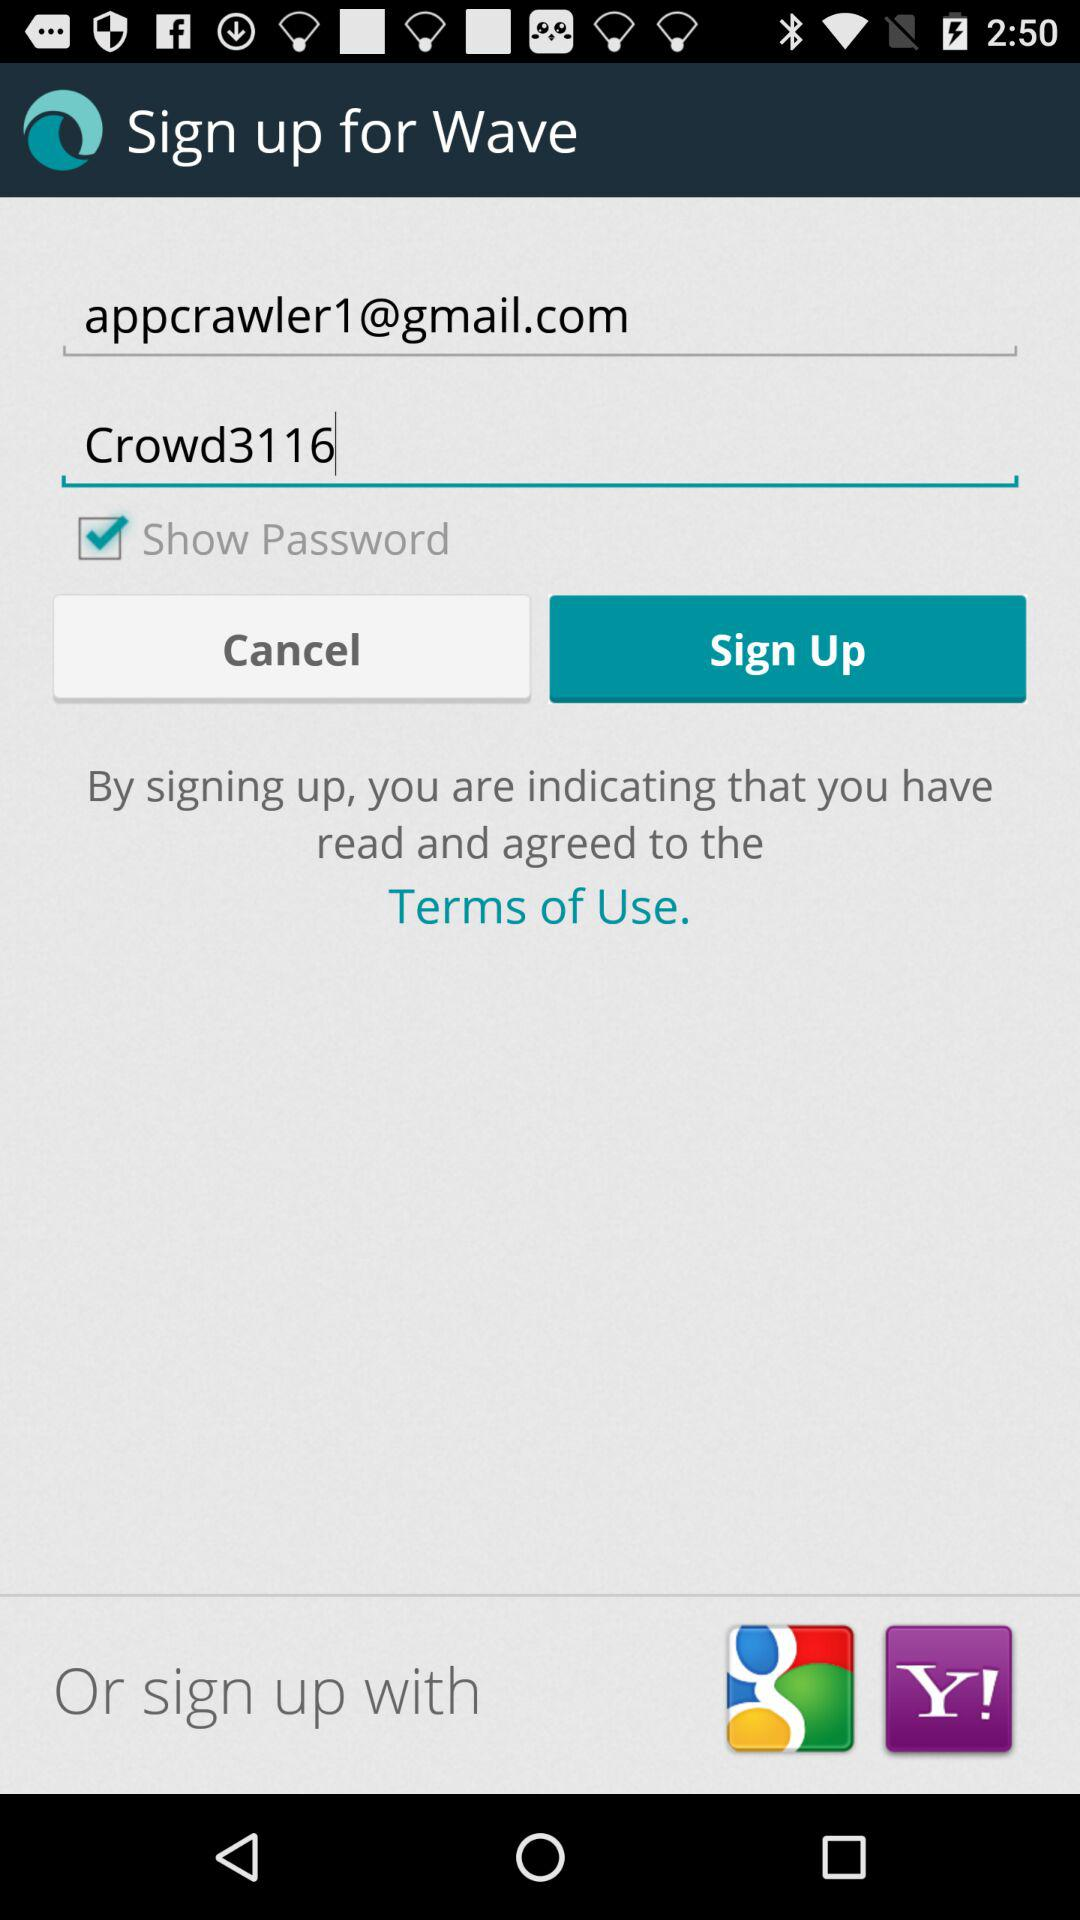What is the password? The password is "Crowd3116". 